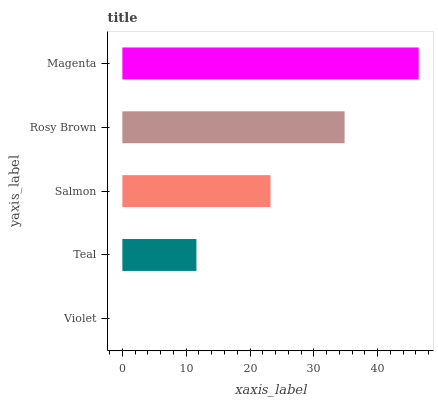Is Violet the minimum?
Answer yes or no. Yes. Is Magenta the maximum?
Answer yes or no. Yes. Is Teal the minimum?
Answer yes or no. No. Is Teal the maximum?
Answer yes or no. No. Is Teal greater than Violet?
Answer yes or no. Yes. Is Violet less than Teal?
Answer yes or no. Yes. Is Violet greater than Teal?
Answer yes or no. No. Is Teal less than Violet?
Answer yes or no. No. Is Salmon the high median?
Answer yes or no. Yes. Is Salmon the low median?
Answer yes or no. Yes. Is Magenta the high median?
Answer yes or no. No. Is Violet the low median?
Answer yes or no. No. 